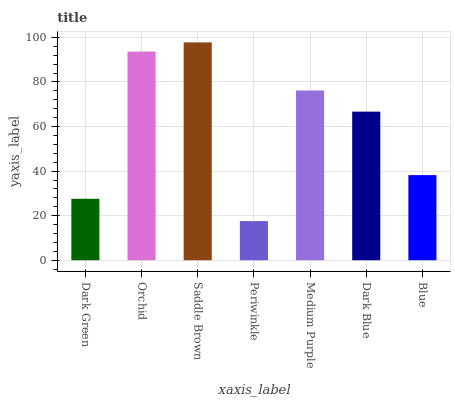Is Periwinkle the minimum?
Answer yes or no. Yes. Is Saddle Brown the maximum?
Answer yes or no. Yes. Is Orchid the minimum?
Answer yes or no. No. Is Orchid the maximum?
Answer yes or no. No. Is Orchid greater than Dark Green?
Answer yes or no. Yes. Is Dark Green less than Orchid?
Answer yes or no. Yes. Is Dark Green greater than Orchid?
Answer yes or no. No. Is Orchid less than Dark Green?
Answer yes or no. No. Is Dark Blue the high median?
Answer yes or no. Yes. Is Dark Blue the low median?
Answer yes or no. Yes. Is Saddle Brown the high median?
Answer yes or no. No. Is Saddle Brown the low median?
Answer yes or no. No. 